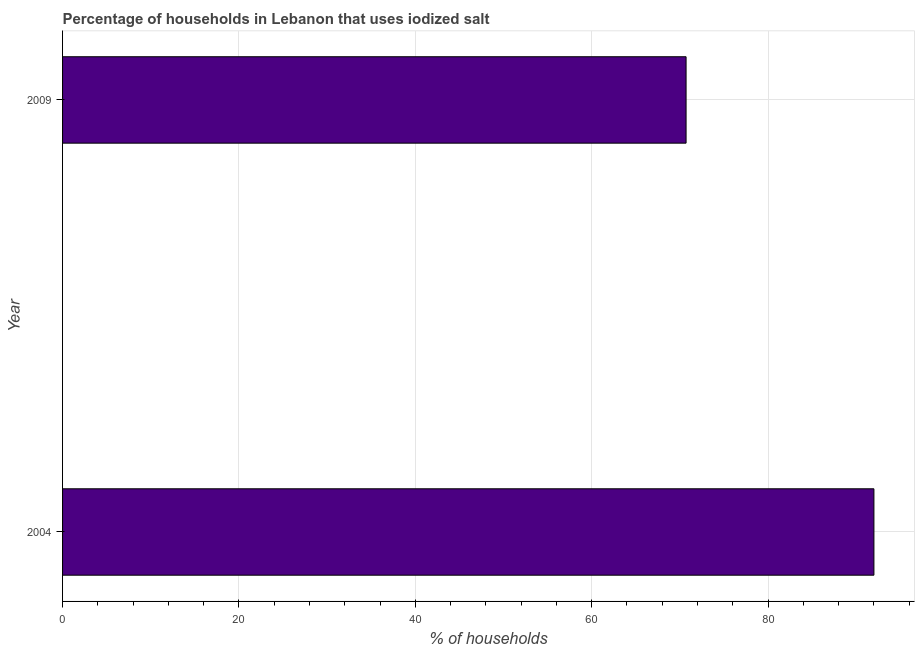What is the title of the graph?
Offer a terse response. Percentage of households in Lebanon that uses iodized salt. What is the label or title of the X-axis?
Keep it short and to the point. % of households. What is the label or title of the Y-axis?
Provide a succinct answer. Year. What is the percentage of households where iodized salt is consumed in 2004?
Provide a short and direct response. 92. Across all years, what is the maximum percentage of households where iodized salt is consumed?
Ensure brevity in your answer.  92. Across all years, what is the minimum percentage of households where iodized salt is consumed?
Provide a succinct answer. 70.7. What is the sum of the percentage of households where iodized salt is consumed?
Make the answer very short. 162.7. What is the difference between the percentage of households where iodized salt is consumed in 2004 and 2009?
Keep it short and to the point. 21.3. What is the average percentage of households where iodized salt is consumed per year?
Provide a succinct answer. 81.35. What is the median percentage of households where iodized salt is consumed?
Offer a very short reply. 81.35. What is the ratio of the percentage of households where iodized salt is consumed in 2004 to that in 2009?
Give a very brief answer. 1.3. Is the percentage of households where iodized salt is consumed in 2004 less than that in 2009?
Offer a terse response. No. In how many years, is the percentage of households where iodized salt is consumed greater than the average percentage of households where iodized salt is consumed taken over all years?
Offer a terse response. 1. How many bars are there?
Offer a terse response. 2. Are all the bars in the graph horizontal?
Offer a terse response. Yes. Are the values on the major ticks of X-axis written in scientific E-notation?
Give a very brief answer. No. What is the % of households of 2004?
Ensure brevity in your answer.  92. What is the % of households of 2009?
Your answer should be very brief. 70.7. What is the difference between the % of households in 2004 and 2009?
Give a very brief answer. 21.3. What is the ratio of the % of households in 2004 to that in 2009?
Provide a succinct answer. 1.3. 